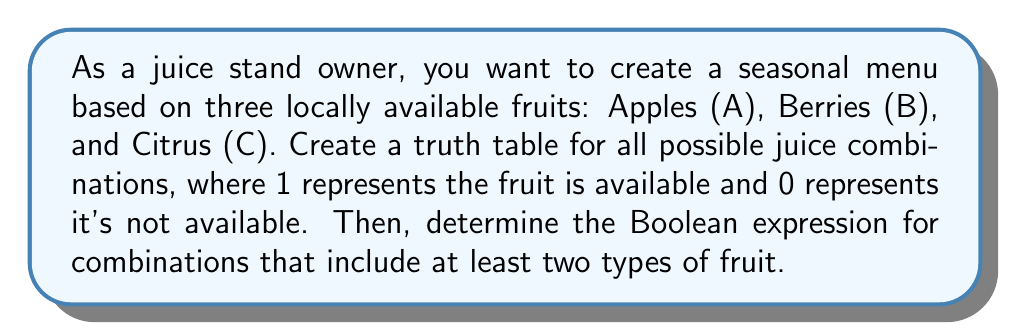Teach me how to tackle this problem. Let's approach this step-by-step:

1. Create the truth table:
   We have 3 variables (A, B, C), so we'll have $2^3 = 8$ rows.

   $$ \begin{array}{|c|c|c|c|}
   \hline
   A & B & C & \text{Output} \\
   \hline
   0 & 0 & 0 & 0 \\
   0 & 0 & 1 & 0 \\
   0 & 1 & 0 & 0 \\
   0 & 1 & 1 & 1 \\
   1 & 0 & 0 & 0 \\
   1 & 0 & 1 & 1 \\
   1 & 1 & 0 & 1 \\
   1 & 1 & 1 & 1 \\
   \hline
   \end{array} $$

2. Identify the rows where the output is 1 (at least two fruits available):
   - $A=0, B=1, C=1$
   - $A=1, B=0, C=1$
   - $A=1, B=1, C=0$
   - $A=1, B=1, C=1$

3. Write the Boolean expression for each of these rows:
   - $\overline{A} \cdot B \cdot C$
   - $A \cdot \overline{B} \cdot C$
   - $A \cdot B \cdot \overline{C}$
   - $A \cdot B \cdot C$

4. Combine these expressions using the OR operator:
   $F = \overline{A}BC + A\overline{B}C + AB\overline{C} + ABC$

This Boolean expression represents all combinations where at least two types of fruit are available.
Answer: $F = \overline{A}BC + A\overline{B}C + AB\overline{C} + ABC$ 